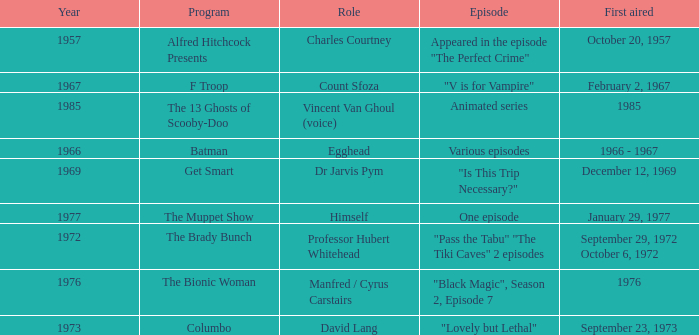What's the roles of the Bionic Woman? Manfred / Cyrus Carstairs. 